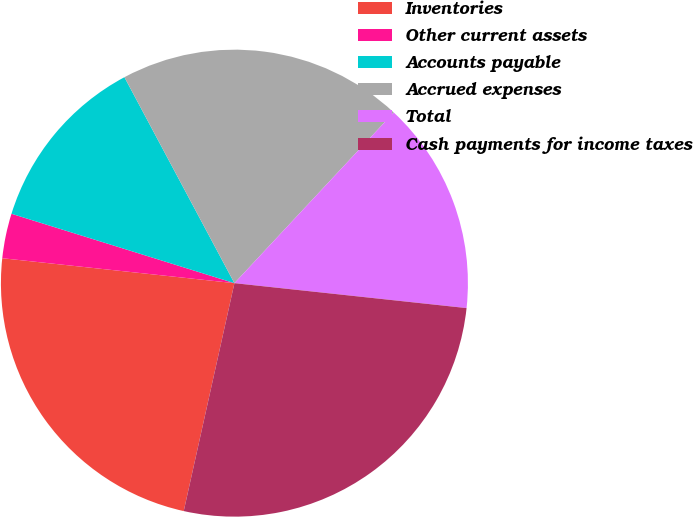Convert chart. <chart><loc_0><loc_0><loc_500><loc_500><pie_chart><fcel>Inventories<fcel>Other current assets<fcel>Accounts payable<fcel>Accrued expenses<fcel>Total<fcel>Cash payments for income taxes<nl><fcel>23.22%<fcel>3.1%<fcel>12.39%<fcel>19.76%<fcel>14.75%<fcel>26.78%<nl></chart> 